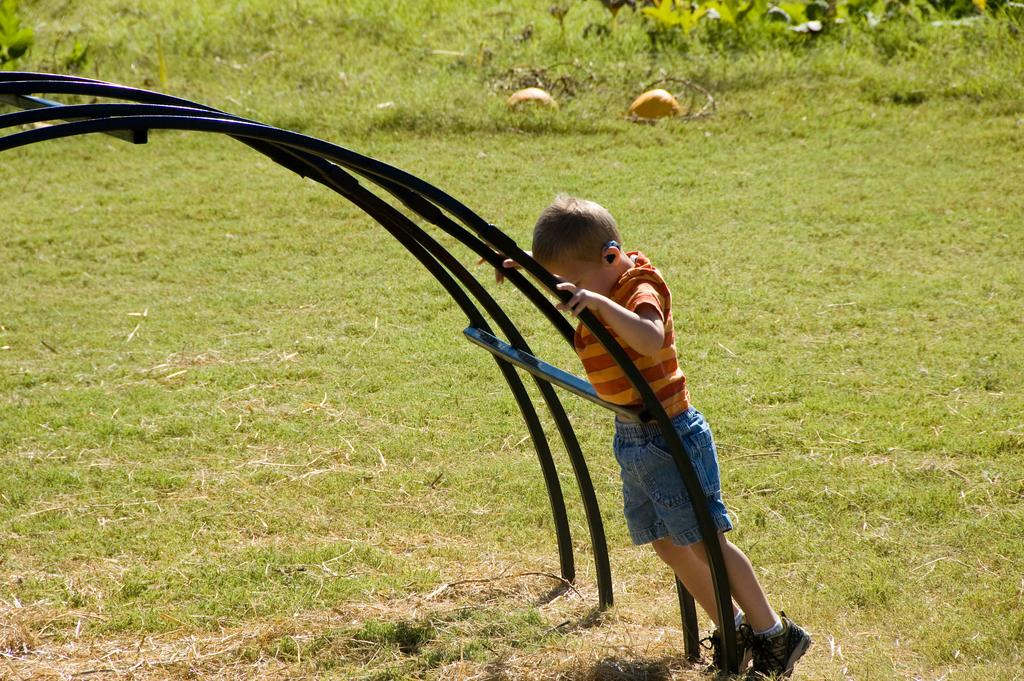Who is the main subject in the image? There is a boy in the image. Where is the boy located? The boy is standing on a path. What can be seen on the left side of the boy? There are iron rods on the left side of the boy. What type of vegetation is visible in the image? There are plants visible in the image. What is the ground covered with in the image? There is grass in the image. What type of throne is the boy sitting on in the image? There is no throne present in the image; the boy is standing on a path. Can you see the moon in the image? The moon is not visible in the image; it is a daytime scene with grass and plants. 